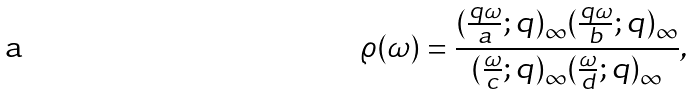Convert formula to latex. <formula><loc_0><loc_0><loc_500><loc_500>\varrho ( \omega ) = \frac { ( \frac { q \omega } { a } ; q ) _ { \infty } ( \frac { q \omega } { b } ; q ) _ { \infty } } { ( \frac { \omega } { c } ; q ) _ { \infty } ( \frac { \omega } { d } ; q ) _ { \infty } } ,</formula> 